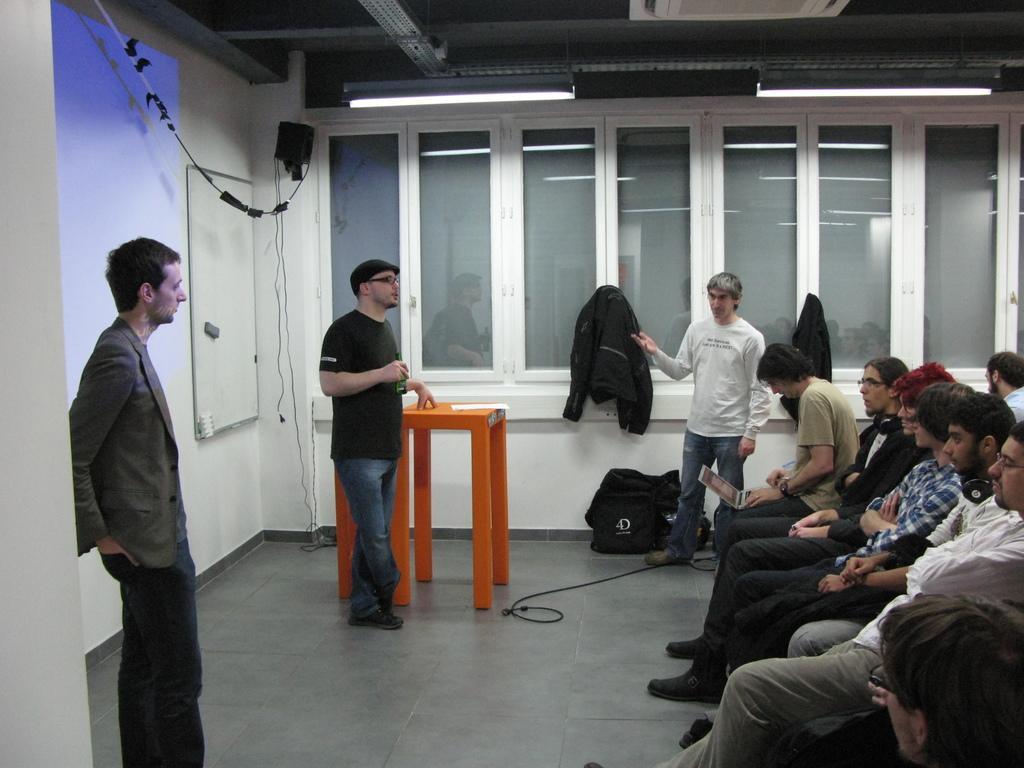Could you give a brief overview of what you see in this image? In this picture we can see the inside view of a building. On the right side of the image, there is a group of people sitting. There are three men standing on the floor. On the left side of the image, there is a wall, a whiteboard and cables. Behind the two men, there is an orange table, windows and some objects. At the top of the image, there are ceiling lights. 